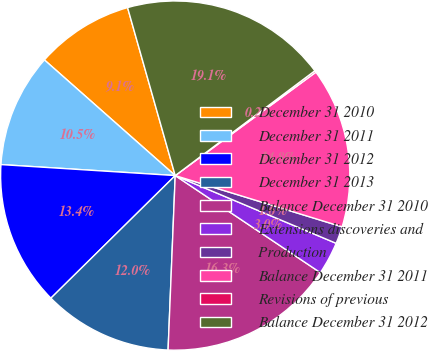Convert chart to OTSL. <chart><loc_0><loc_0><loc_500><loc_500><pie_chart><fcel>December 31 2010<fcel>December 31 2011<fcel>December 31 2012<fcel>December 31 2013<fcel>Balance December 31 2010<fcel>Extensions discoveries and<fcel>Production<fcel>Balance December 31 2011<fcel>Revisions of previous<fcel>Balance December 31 2012<nl><fcel>9.08%<fcel>10.52%<fcel>13.39%<fcel>11.96%<fcel>16.27%<fcel>3.04%<fcel>1.6%<fcel>14.83%<fcel>0.16%<fcel>19.15%<nl></chart> 